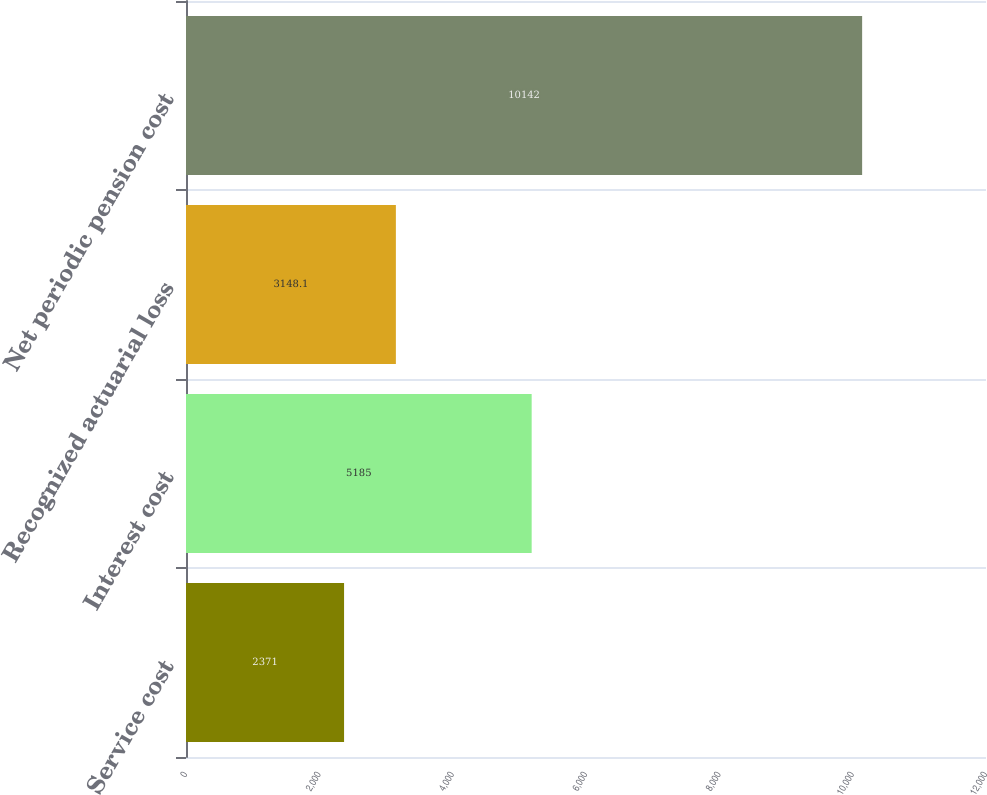Convert chart. <chart><loc_0><loc_0><loc_500><loc_500><bar_chart><fcel>Service cost<fcel>Interest cost<fcel>Recognized actuarial loss<fcel>Net periodic pension cost<nl><fcel>2371<fcel>5185<fcel>3148.1<fcel>10142<nl></chart> 